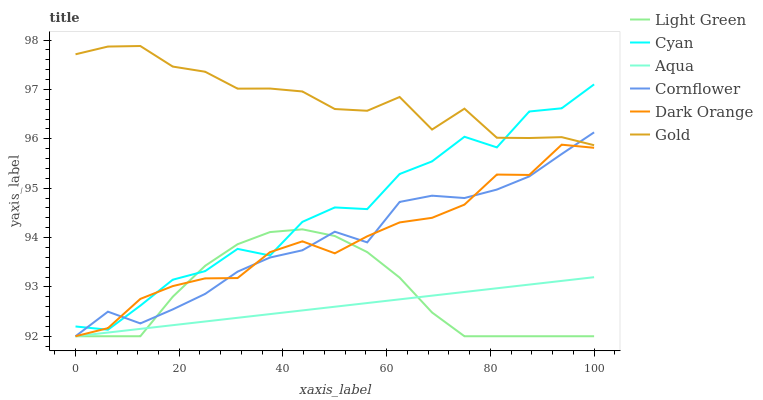Does Aqua have the minimum area under the curve?
Answer yes or no. Yes. Does Gold have the maximum area under the curve?
Answer yes or no. Yes. Does Cornflower have the minimum area under the curve?
Answer yes or no. No. Does Cornflower have the maximum area under the curve?
Answer yes or no. No. Is Aqua the smoothest?
Answer yes or no. Yes. Is Cyan the roughest?
Answer yes or no. Yes. Is Gold the smoothest?
Answer yes or no. No. Is Gold the roughest?
Answer yes or no. No. Does Gold have the lowest value?
Answer yes or no. No. Does Gold have the highest value?
Answer yes or no. Yes. Does Cornflower have the highest value?
Answer yes or no. No. Is Aqua less than Cyan?
Answer yes or no. Yes. Is Cyan greater than Aqua?
Answer yes or no. Yes. Does Cyan intersect Light Green?
Answer yes or no. Yes. Is Cyan less than Light Green?
Answer yes or no. No. Is Cyan greater than Light Green?
Answer yes or no. No. Does Aqua intersect Cyan?
Answer yes or no. No. 